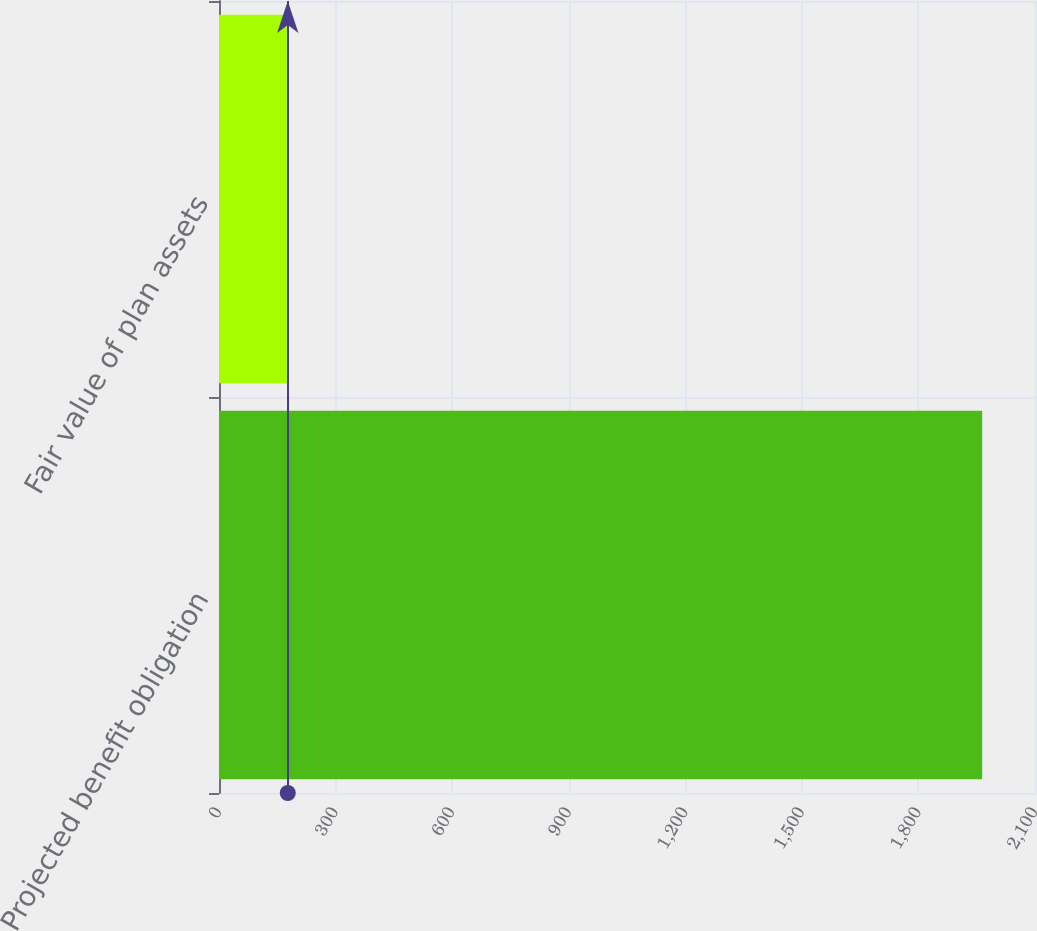Convert chart to OTSL. <chart><loc_0><loc_0><loc_500><loc_500><bar_chart><fcel>Projected benefit obligation<fcel>Fair value of plan assets<nl><fcel>1964<fcel>177<nl></chart> 